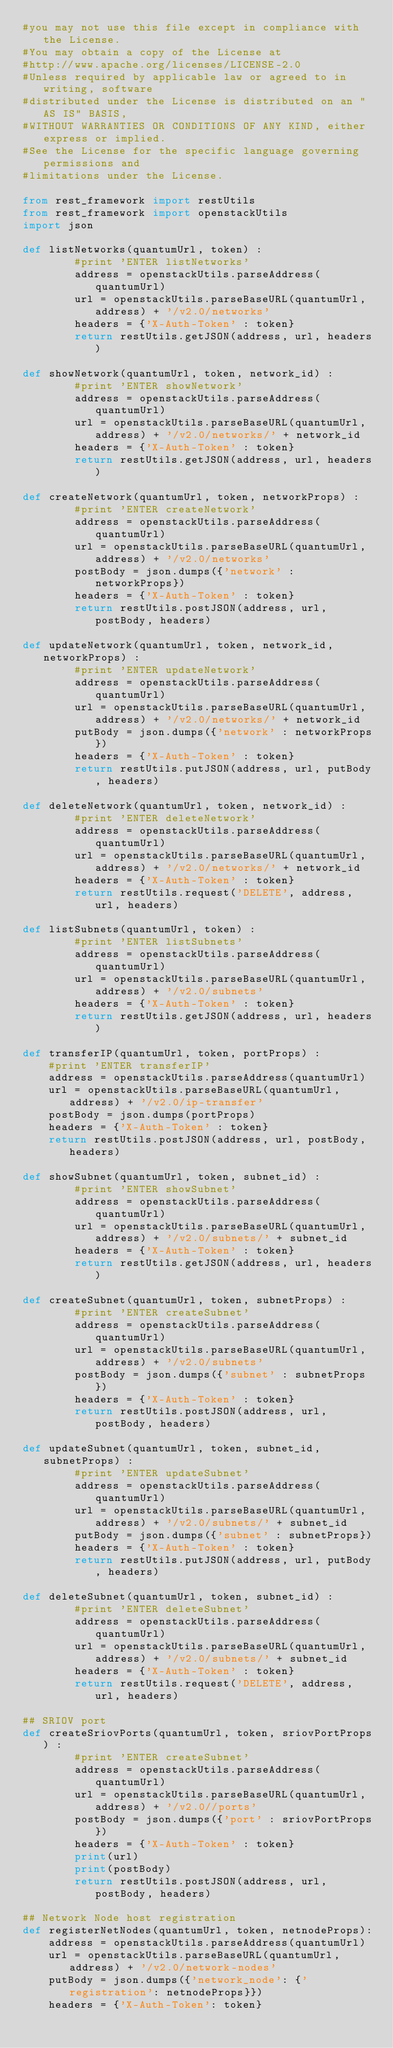<code> <loc_0><loc_0><loc_500><loc_500><_Python_>#you may not use this file except in compliance with the License.
#You may obtain a copy of the License at
#http://www.apache.org/licenses/LICENSE-2.0
#Unless required by applicable law or agreed to in writing, software
#distributed under the License is distributed on an "AS IS" BASIS,
#WITHOUT WARRANTIES OR CONDITIONS OF ANY KIND, either express or implied.
#See the License for the specific language governing permissions and
#limitations under the License.

from rest_framework import restUtils
from rest_framework import openstackUtils
import json

def listNetworks(quantumUrl, token) :
        #print 'ENTER listNetworks'
        address = openstackUtils.parseAddress(quantumUrl)
        url = openstackUtils.parseBaseURL(quantumUrl, address) + '/v2.0/networks'
        headers = {'X-Auth-Token' : token}
        return restUtils.getJSON(address, url, headers)

def showNetwork(quantumUrl, token, network_id) :
        #print 'ENTER showNetwork'
        address = openstackUtils.parseAddress(quantumUrl)
        url = openstackUtils.parseBaseURL(quantumUrl, address) + '/v2.0/networks/' + network_id
        headers = {'X-Auth-Token' : token}
        return restUtils.getJSON(address, url, headers)

def createNetwork(quantumUrl, token, networkProps) :
        #print 'ENTER createNetwork'
        address = openstackUtils.parseAddress(quantumUrl)
        url = openstackUtils.parseBaseURL(quantumUrl, address) + '/v2.0/networks'
        postBody = json.dumps({'network' : networkProps})
        headers = {'X-Auth-Token' : token}
        return restUtils.postJSON(address, url, postBody, headers)

def updateNetwork(quantumUrl, token, network_id, networkProps) :
        #print 'ENTER updateNetwork'
        address = openstackUtils.parseAddress(quantumUrl)
        url = openstackUtils.parseBaseURL(quantumUrl, address) + '/v2.0/networks/' + network_id
        putBody = json.dumps({'network' : networkProps})
        headers = {'X-Auth-Token' : token}
        return restUtils.putJSON(address, url, putBody, headers)

def deleteNetwork(quantumUrl, token, network_id) :
        #print 'ENTER deleteNetwork'
        address = openstackUtils.parseAddress(quantumUrl)
        url = openstackUtils.parseBaseURL(quantumUrl, address) + '/v2.0/networks/' + network_id
        headers = {'X-Auth-Token' : token}
        return restUtils.request('DELETE', address, url, headers)

def listSubnets(quantumUrl, token) :
        #print 'ENTER listSubnets'
        address = openstackUtils.parseAddress(quantumUrl)
        url = openstackUtils.parseBaseURL(quantumUrl, address) + '/v2.0/subnets'
        headers = {'X-Auth-Token' : token}
        return restUtils.getJSON(address, url, headers)

def transferIP(quantumUrl, token, portProps) :
    #print 'ENTER transferIP'
    address = openstackUtils.parseAddress(quantumUrl)
    url = openstackUtils.parseBaseURL(quantumUrl, address) + '/v2.0/ip-transfer'
    postBody = json.dumps(portProps)
    headers = {'X-Auth-Token' : token}
    return restUtils.postJSON(address, url, postBody, headers)

def showSubnet(quantumUrl, token, subnet_id) :
        #print 'ENTER showSubnet'
        address = openstackUtils.parseAddress(quantumUrl)
        url = openstackUtils.parseBaseURL(quantumUrl, address) + '/v2.0/subnets/' + subnet_id
        headers = {'X-Auth-Token' : token}
        return restUtils.getJSON(address, url, headers)

def createSubnet(quantumUrl, token, subnetProps) :
        #print 'ENTER createSubnet'
        address = openstackUtils.parseAddress(quantumUrl)
        url = openstackUtils.parseBaseURL(quantumUrl, address) + '/v2.0/subnets'
        postBody = json.dumps({'subnet' : subnetProps})
        headers = {'X-Auth-Token' : token}
        return restUtils.postJSON(address, url, postBody, headers)

def updateSubnet(quantumUrl, token, subnet_id, subnetProps) :
        #print 'ENTER updateSubnet'
        address = openstackUtils.parseAddress(quantumUrl)
        url = openstackUtils.parseBaseURL(quantumUrl, address) + '/v2.0/subnets/' + subnet_id
        putBody = json.dumps({'subnet' : subnetProps})
        headers = {'X-Auth-Token' : token}
        return restUtils.putJSON(address, url, putBody, headers)

def deleteSubnet(quantumUrl, token, subnet_id) :
        #print 'ENTER deleteSubnet'
        address = openstackUtils.parseAddress(quantumUrl)
        url = openstackUtils.parseBaseURL(quantumUrl, address) + '/v2.0/subnets/' + subnet_id
        headers = {'X-Auth-Token' : token}
        return restUtils.request('DELETE', address, url, headers)

## SRIOV port
def createSriovPorts(quantumUrl, token, sriovPortProps) :
        #print 'ENTER createSubnet'
        address = openstackUtils.parseAddress(quantumUrl)
        url = openstackUtils.parseBaseURL(quantumUrl, address) + '/v2.0//ports'
        postBody = json.dumps({'port' : sriovPortProps})
        headers = {'X-Auth-Token' : token}
        print(url)
        print(postBody)
        return restUtils.postJSON(address, url, postBody, headers)

## Network Node host registration
def registerNetNodes(quantumUrl, token, netnodeProps):
    address = openstackUtils.parseAddress(quantumUrl)
    url = openstackUtils.parseBaseURL(quantumUrl, address) + '/v2.0/network-nodes'
    putBody = json.dumps({'network_node': {'registration': netnodeProps}})
    headers = {'X-Auth-Token': token}</code> 